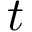<formula> <loc_0><loc_0><loc_500><loc_500>t</formula> 